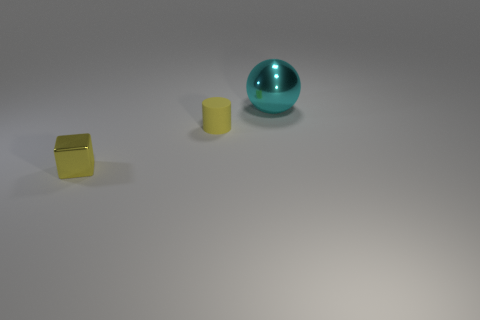Add 2 tiny blue shiny blocks. How many objects exist? 5 Subtract all spheres. How many objects are left? 2 Add 1 big cyan objects. How many big cyan objects are left? 2 Add 3 small yellow balls. How many small yellow balls exist? 3 Subtract 0 green cylinders. How many objects are left? 3 Subtract all brown matte cylinders. Subtract all small rubber objects. How many objects are left? 2 